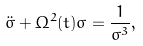Convert formula to latex. <formula><loc_0><loc_0><loc_500><loc_500>\ddot { \sigma } + \Omega ^ { 2 } ( t ) \sigma = \frac { 1 } { \sigma ^ { 3 } } ,</formula> 